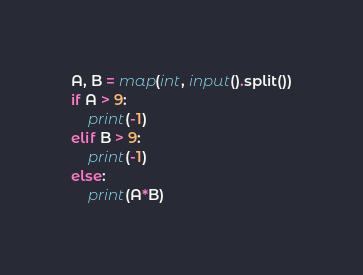<code> <loc_0><loc_0><loc_500><loc_500><_Python_>A, B = map(int, input().split())
if A > 9:
    print(-1)
elif B > 9:
    print(-1)
else:
    print(A*B)
</code> 